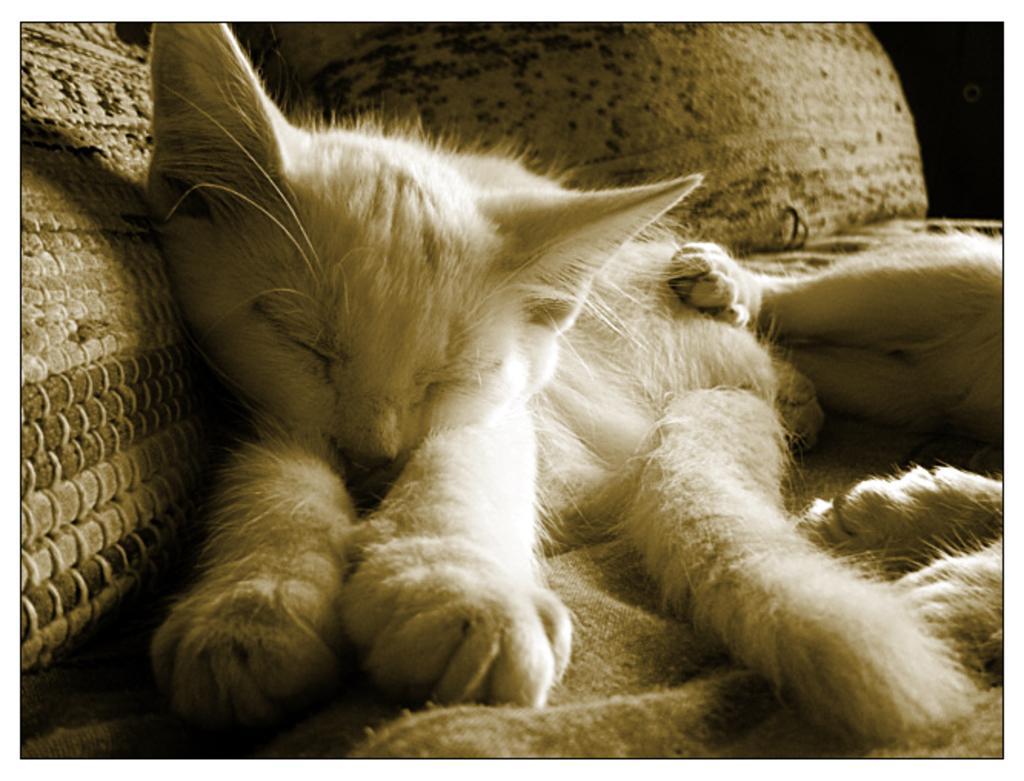In one or two sentences, can you explain what this image depicts? There are two cats present in the middle of this image. It seems like pillows in the background. 